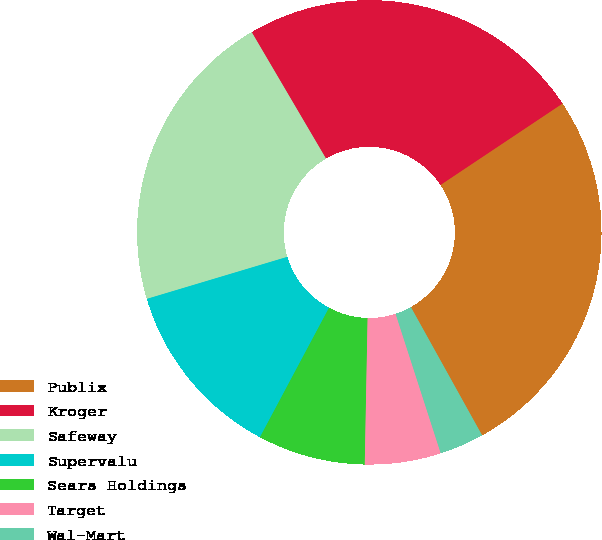Convert chart to OTSL. <chart><loc_0><loc_0><loc_500><loc_500><pie_chart><fcel>Publix<fcel>Kroger<fcel>Safeway<fcel>Supervalu<fcel>Sears Holdings<fcel>Target<fcel>Wal-Mart<nl><fcel>26.29%<fcel>24.09%<fcel>21.17%<fcel>12.57%<fcel>7.49%<fcel>5.29%<fcel>3.09%<nl></chart> 